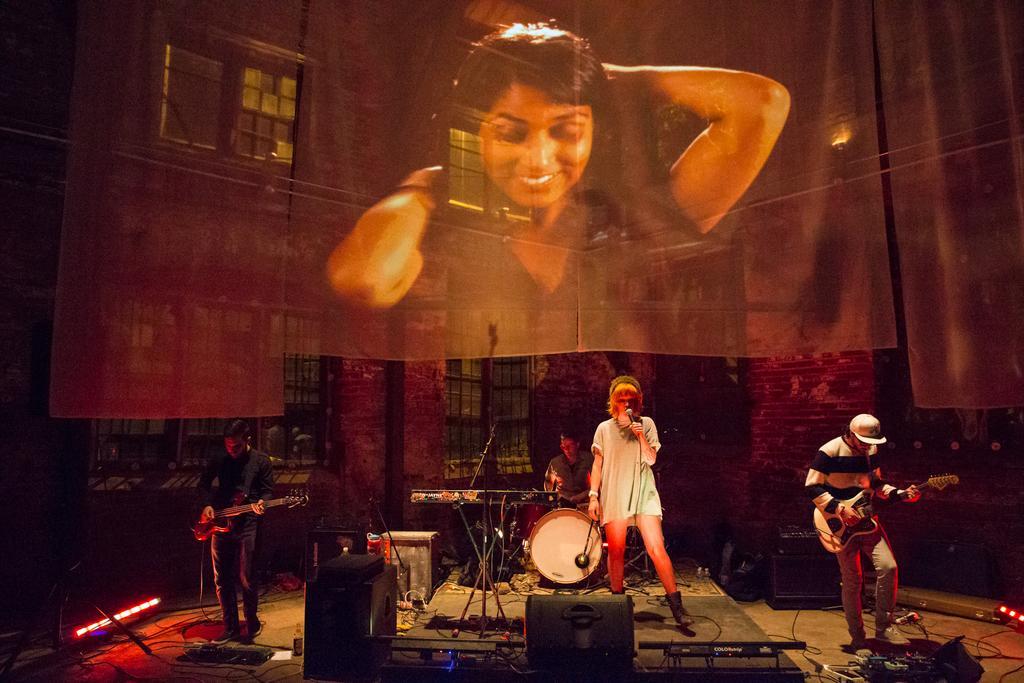In one or two sentences, can you explain what this image depicts? In this picture we can see four people, musical instruments, speakers, cables, lights, mic and some objects and two men are holding guitars with their hands and in the background we can see windows, clothes and a woman smiling. 